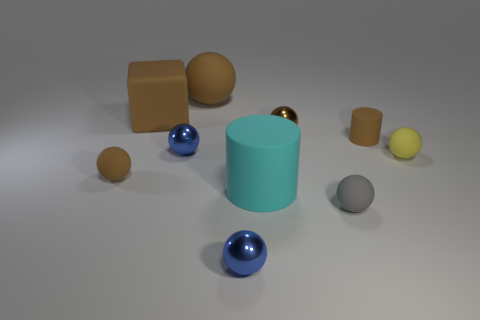Does the cube have the same color as the small cylinder?
Keep it short and to the point. Yes. There is a rubber object that is left of the large rubber sphere and behind the small brown metallic sphere; what size is it?
Provide a succinct answer. Large. What number of cyan objects are the same size as the brown metallic thing?
Offer a very short reply. 0. What is the material of the other thing that is the same shape as the cyan rubber object?
Your response must be concise. Rubber. Do the tiny brown metal object and the big cyan object have the same shape?
Keep it short and to the point. No. There is a tiny yellow matte thing; how many tiny gray balls are left of it?
Your answer should be very brief. 1. What shape is the tiny rubber object to the left of the small brown ball that is right of the brown rubber block?
Offer a terse response. Sphere. What shape is the small gray object that is the same material as the small yellow sphere?
Your response must be concise. Sphere. Is the size of the brown ball that is behind the brown shiny thing the same as the matte cylinder that is left of the small brown shiny object?
Offer a very short reply. Yes. There is a metal thing that is in front of the tiny yellow matte ball; what is its shape?
Your answer should be very brief. Sphere. 